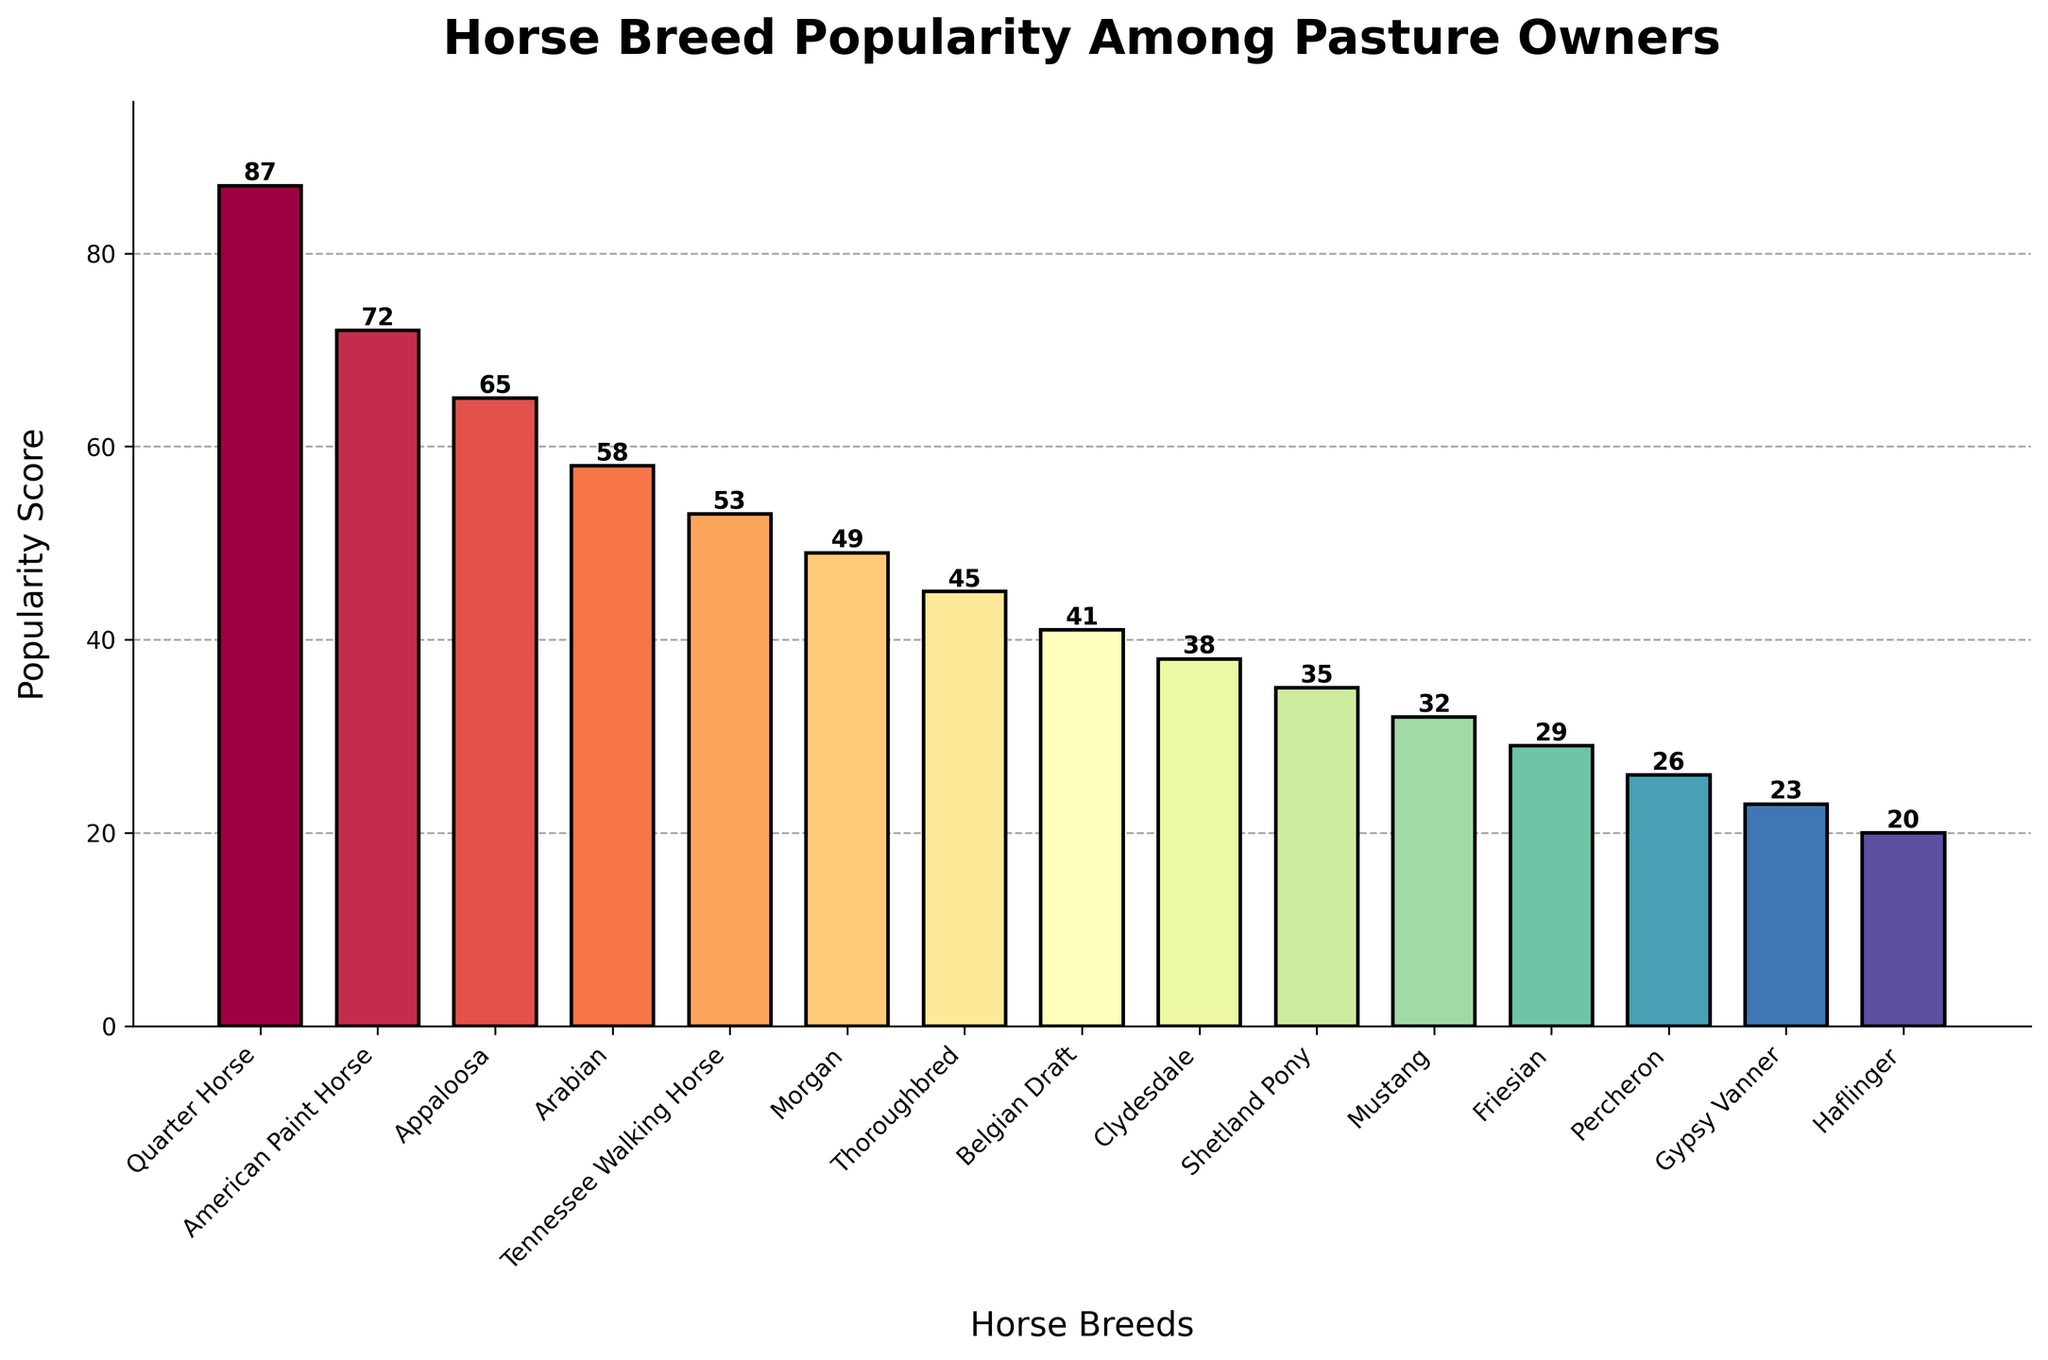What's the most popular horse breed among pasture owners? The bar representing the Quarter Horse is the tallest, indicating it has the highest popularity score among the breeds.
Answer: Quarter Horse Which horse breed has the lowest popularity score? The bar representing the Haflinger is the shortest, indicating it has the lowest popularity score among the breeds.
Answer: Haflinger How many horse breeds have a popularity score greater than 50? By observing the bars and their height relative to the score axis, you can count the bars with scores greater than 50: Quarter Horse, American Paint Horse, Appaloosa, Arabian, and Tennessee Walking Horse.
Answer: 5 Compare the popularity of the Thoroughbred and American Paint Horse. Which one is more popular, and by how much? The height of the Thoroughbred bar is 45, while the height of the American Paint Horse bar is 72. To find the difference, subtract 45 from 72.
Answer: American Paint Horse by 27 What is the combined popularity score of the top three most popular breeds? The popularity scores for the top three breeds are: Quarter Horse (87), American Paint Horse (72), and Appaloosa (65). Adding these together gives 87 + 72 + 65 = 224.
Answer: 224 Which breed has a popularity score that is the median value when all breeds are considered? There are 15 breeds, which means the median is the 8th value when they are sorted by score. The sorted scores are: 20, 23, 26, 29, 32, 35, 38, 41, 45, 49, 53, 58, 65, 72, 87. The 8th value is 41, corresponding to the Belgian Draft.
Answer: Belgian Draft Which breeds have a popularity score that is less than 40? The breeds with bars lower than the 40 mark are Clydesdale (38), Shetland Pony (35), Mustang (32), Friesian (29), Percheron (26), Gypsy Vanner (23), and Haflinger (20).
Answer: 7 (Clydesdale, Shetland Pony, Mustang, Friesian, Percheron, Gypsy Vanner, Haflinger) By how much does the popularity score of a Morgan horse differ from that of a Friesian horse? The popularity score for a Morgan horse is 49 and for a Friesian horse is 29. The difference is 49 - 29 = 20.
Answer: 20 Do any horse breeds have a popularity score exactly equal to 50? By observing the bars, none of them reach exactly 50 on the score axis.
Answer: No 